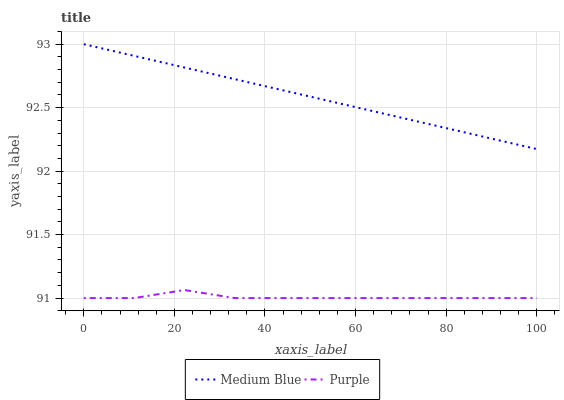Does Purple have the minimum area under the curve?
Answer yes or no. Yes. Does Medium Blue have the maximum area under the curve?
Answer yes or no. Yes. Does Medium Blue have the minimum area under the curve?
Answer yes or no. No. Is Medium Blue the smoothest?
Answer yes or no. Yes. Is Purple the roughest?
Answer yes or no. Yes. Is Medium Blue the roughest?
Answer yes or no. No. Does Medium Blue have the lowest value?
Answer yes or no. No. Does Medium Blue have the highest value?
Answer yes or no. Yes. Is Purple less than Medium Blue?
Answer yes or no. Yes. Is Medium Blue greater than Purple?
Answer yes or no. Yes. Does Purple intersect Medium Blue?
Answer yes or no. No. 